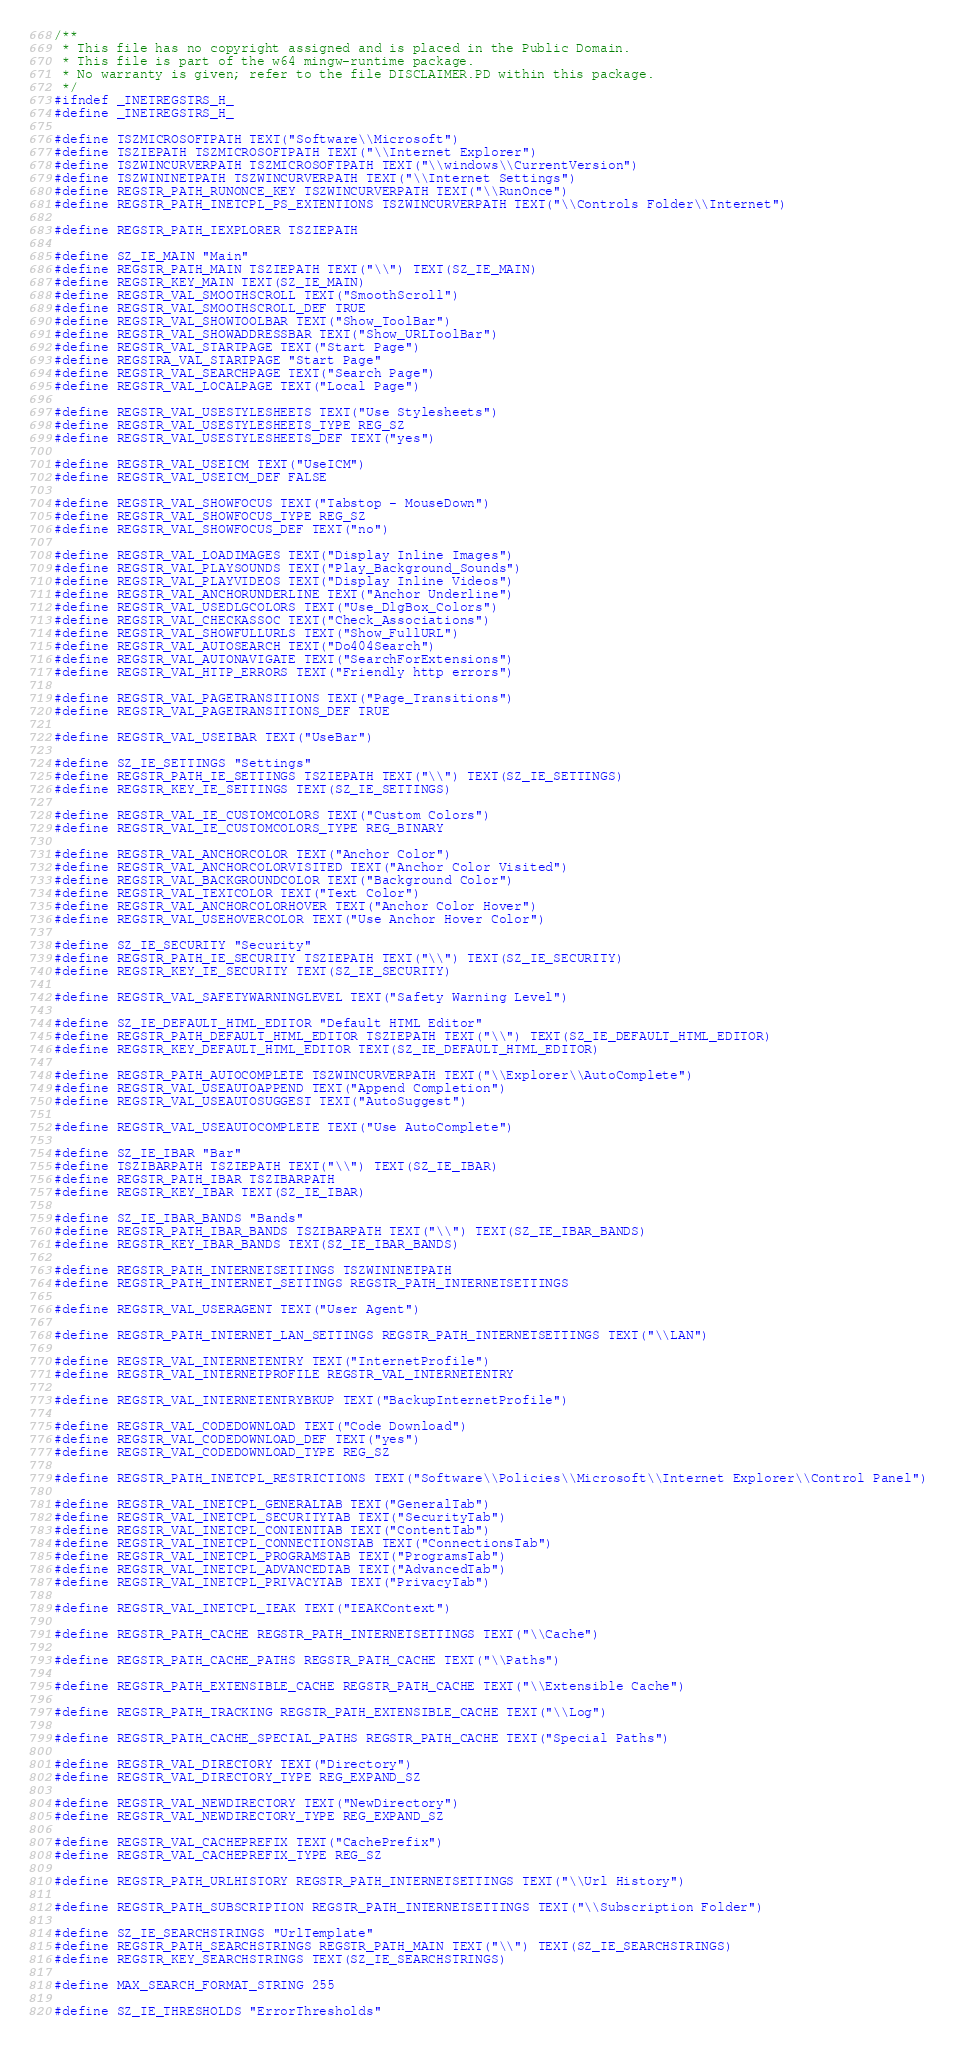<code> <loc_0><loc_0><loc_500><loc_500><_C_>/**
 * This file has no copyright assigned and is placed in the Public Domain.
 * This file is part of the w64 mingw-runtime package.
 * No warranty is given; refer to the file DISCLAIMER.PD within this package.
 */
#ifndef _INETREGSTRS_H_
#define _INETREGSTRS_H_

#define TSZMICROSOFTPATH TEXT("Software\\Microsoft")
#define TSZIEPATH TSZMICROSOFTPATH TEXT("\\Internet Explorer")
#define TSZWINCURVERPATH TSZMICROSOFTPATH TEXT("\\windows\\CurrentVersion")
#define TSZWININETPATH TSZWINCURVERPATH TEXT("\\Internet Settings")
#define REGSTR_PATH_RUNONCE_KEY TSZWINCURVERPATH TEXT("\\RunOnce")
#define REGSTR_PATH_INETCPL_PS_EXTENTIONS TSZWINCURVERPATH TEXT("\\Controls Folder\\Internet")

#define REGSTR_PATH_IEXPLORER TSZIEPATH

#define SZ_IE_MAIN "Main"
#define REGSTR_PATH_MAIN TSZIEPATH TEXT("\\") TEXT(SZ_IE_MAIN)
#define REGSTR_KEY_MAIN TEXT(SZ_IE_MAIN)
#define REGSTR_VAL_SMOOTHSCROLL TEXT("SmoothScroll")
#define REGSTR_VAL_SMOOTHSCROLL_DEF TRUE
#define REGSTR_VAL_SHOWTOOLBAR TEXT("Show_ToolBar")
#define REGSTR_VAL_SHOWADDRESSBAR TEXT("Show_URLToolBar")
#define REGSTR_VAL_STARTPAGE TEXT("Start Page")
#define REGSTRA_VAL_STARTPAGE "Start Page"
#define REGSTR_VAL_SEARCHPAGE TEXT("Search Page")
#define REGSTR_VAL_LOCALPAGE TEXT("Local Page")

#define REGSTR_VAL_USESTYLESHEETS TEXT("Use Stylesheets")
#define REGSTR_VAL_USESTYLESHEETS_TYPE REG_SZ
#define REGSTR_VAL_USESTYLESHEETS_DEF TEXT("yes")

#define REGSTR_VAL_USEICM TEXT("UseICM")
#define REGSTR_VAL_USEICM_DEF FALSE

#define REGSTR_VAL_SHOWFOCUS TEXT("Tabstop - MouseDown")
#define REGSTR_VAL_SHOWFOCUS_TYPE REG_SZ
#define REGSTR_VAL_SHOWFOCUS_DEF TEXT("no")

#define REGSTR_VAL_LOADIMAGES TEXT("Display Inline Images")
#define REGSTR_VAL_PLAYSOUNDS TEXT("Play_Background_Sounds")
#define REGSTR_VAL_PLAYVIDEOS TEXT("Display Inline Videos")
#define REGSTR_VAL_ANCHORUNDERLINE TEXT("Anchor Underline")
#define REGSTR_VAL_USEDLGCOLORS TEXT("Use_DlgBox_Colors")
#define REGSTR_VAL_CHECKASSOC TEXT("Check_Associations")
#define REGSTR_VAL_SHOWFULLURLS TEXT("Show_FullURL")
#define REGSTR_VAL_AUTOSEARCH TEXT("Do404Search")
#define REGSTR_VAL_AUTONAVIGATE TEXT("SearchForExtensions")
#define REGSTR_VAL_HTTP_ERRORS TEXT("Friendly http errors")

#define REGSTR_VAL_PAGETRANSITIONS TEXT("Page_Transitions")
#define REGSTR_VAL_PAGETRANSITIONS_DEF TRUE

#define REGSTR_VAL_USEIBAR TEXT("UseBar")

#define SZ_IE_SETTINGS "Settings"
#define REGSTR_PATH_IE_SETTINGS TSZIEPATH TEXT("\\") TEXT(SZ_IE_SETTINGS)
#define REGSTR_KEY_IE_SETTINGS TEXT(SZ_IE_SETTINGS)

#define REGSTR_VAL_IE_CUSTOMCOLORS TEXT("Custom Colors")
#define REGSTR_VAL_IE_CUSTOMCOLORS_TYPE REG_BINARY

#define REGSTR_VAL_ANCHORCOLOR TEXT("Anchor Color")
#define REGSTR_VAL_ANCHORCOLORVISITED TEXT("Anchor Color Visited")
#define REGSTR_VAL_BACKGROUNDCOLOR TEXT("Background Color")
#define REGSTR_VAL_TEXTCOLOR TEXT("Text Color")
#define REGSTR_VAL_ANCHORCOLORHOVER TEXT("Anchor Color Hover")
#define REGSTR_VAL_USEHOVERCOLOR TEXT("Use Anchor Hover Color")

#define SZ_IE_SECURITY "Security"
#define REGSTR_PATH_IE_SECURITY TSZIEPATH TEXT("\\") TEXT(SZ_IE_SECURITY)
#define REGSTR_KEY_IE_SECURITY TEXT(SZ_IE_SECURITY)

#define REGSTR_VAL_SAFETYWARNINGLEVEL TEXT("Safety Warning Level")

#define SZ_IE_DEFAULT_HTML_EDITOR "Default HTML Editor"
#define REGSTR_PATH_DEFAULT_HTML_EDITOR TSZIEPATH TEXT("\\") TEXT(SZ_IE_DEFAULT_HTML_EDITOR)
#define REGSTR_KEY_DEFAULT_HTML_EDITOR TEXT(SZ_IE_DEFAULT_HTML_EDITOR)

#define REGSTR_PATH_AUTOCOMPLETE TSZWINCURVERPATH TEXT("\\Explorer\\AutoComplete")
#define REGSTR_VAL_USEAUTOAPPEND TEXT("Append Completion")
#define REGSTR_VAL_USEAUTOSUGGEST TEXT("AutoSuggest")

#define REGSTR_VAL_USEAUTOCOMPLETE TEXT("Use AutoComplete")

#define SZ_IE_IBAR "Bar"
#define TSZIBARPATH TSZIEPATH TEXT("\\") TEXT(SZ_IE_IBAR)
#define REGSTR_PATH_IBAR TSZIBARPATH
#define REGSTR_KEY_IBAR TEXT(SZ_IE_IBAR)

#define SZ_IE_IBAR_BANDS "Bands"
#define REGSTR_PATH_IBAR_BANDS TSZIBARPATH TEXT("\\") TEXT(SZ_IE_IBAR_BANDS)
#define REGSTR_KEY_IBAR_BANDS TEXT(SZ_IE_IBAR_BANDS)

#define REGSTR_PATH_INTERNETSETTINGS TSZWININETPATH
#define REGSTR_PATH_INTERNET_SETTINGS REGSTR_PATH_INTERNETSETTINGS

#define REGSTR_VAL_USERAGENT TEXT("User Agent")

#define REGSTR_PATH_INTERNET_LAN_SETTINGS REGSTR_PATH_INTERNETSETTINGS TEXT("\\LAN")

#define REGSTR_VAL_INTERNETENTRY TEXT("InternetProfile")
#define REGSTR_VAL_INTERNETPROFILE REGSTR_VAL_INTERNETENTRY

#define REGSTR_VAL_INTERNETENTRYBKUP TEXT("BackupInternetProfile")

#define REGSTR_VAL_CODEDOWNLOAD TEXT("Code Download")
#define REGSTR_VAL_CODEDOWNLOAD_DEF TEXT("yes")
#define REGSTR_VAL_CODEDOWNLOAD_TYPE REG_SZ

#define REGSTR_PATH_INETCPL_RESTRICTIONS TEXT("Software\\Policies\\Microsoft\\Internet Explorer\\Control Panel")

#define REGSTR_VAL_INETCPL_GENERALTAB TEXT("GeneralTab")
#define REGSTR_VAL_INETCPL_SECURITYTAB TEXT("SecurityTab")
#define REGSTR_VAL_INETCPL_CONTENTTAB TEXT("ContentTab")
#define REGSTR_VAL_INETCPL_CONNECTIONSTAB TEXT("ConnectionsTab")
#define REGSTR_VAL_INETCPL_PROGRAMSTAB TEXT("ProgramsTab")
#define REGSTR_VAL_INETCPL_ADVANCEDTAB TEXT("AdvancedTab")
#define REGSTR_VAL_INETCPL_PRIVACYTAB TEXT("PrivacyTab")

#define REGSTR_VAL_INETCPL_IEAK TEXT("IEAKContext")

#define REGSTR_PATH_CACHE REGSTR_PATH_INTERNETSETTINGS TEXT("\\Cache")

#define REGSTR_PATH_CACHE_PATHS REGSTR_PATH_CACHE TEXT("\\Paths")

#define REGSTR_PATH_EXTENSIBLE_CACHE REGSTR_PATH_CACHE TEXT("\\Extensible Cache")

#define REGSTR_PATH_TRACKING REGSTR_PATH_EXTENSIBLE_CACHE TEXT("\\Log")

#define REGSTR_PATH_CACHE_SPECIAL_PATHS REGSTR_PATH_CACHE TEXT("Special Paths")

#define REGSTR_VAL_DIRECTORY TEXT("Directory")
#define REGSTR_VAL_DIRECTORY_TYPE REG_EXPAND_SZ

#define REGSTR_VAL_NEWDIRECTORY TEXT("NewDirectory")
#define REGSTR_VAL_NEWDIRECTORY_TYPE REG_EXPAND_SZ

#define REGSTR_VAL_CACHEPREFIX TEXT("CachePrefix")
#define REGSTR_VAL_CACHEPREFIX_TYPE REG_SZ

#define REGSTR_PATH_URLHISTORY REGSTR_PATH_INTERNETSETTINGS TEXT("\\Url History")

#define REGSTR_PATH_SUBSCRIPTION REGSTR_PATH_INTERNETSETTINGS TEXT("\\Subscription Folder")

#define SZ_IE_SEARCHSTRINGS "UrlTemplate"
#define REGSTR_PATH_SEARCHSTRINGS REGSTR_PATH_MAIN TEXT("\\") TEXT(SZ_IE_SEARCHSTRINGS)
#define REGSTR_KEY_SEARCHSTRINGS TEXT(SZ_IE_SEARCHSTRINGS)

#define MAX_SEARCH_FORMAT_STRING 255

#define SZ_IE_THRESHOLDS "ErrorThresholds"</code> 